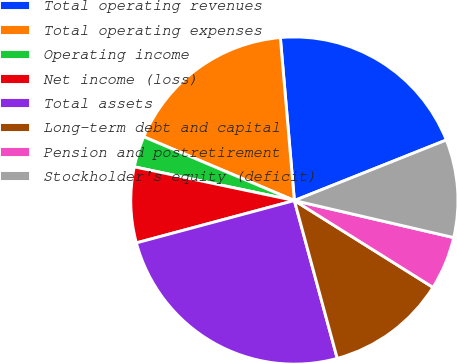Convert chart to OTSL. <chart><loc_0><loc_0><loc_500><loc_500><pie_chart><fcel>Total operating revenues<fcel>Total operating expenses<fcel>Operating income<fcel>Net income (loss)<fcel>Total assets<fcel>Long-term debt and capital<fcel>Pension and postretirement<fcel>Stockholder's equity (deficit)<nl><fcel>20.33%<fcel>17.26%<fcel>3.07%<fcel>7.47%<fcel>25.05%<fcel>11.87%<fcel>5.27%<fcel>9.67%<nl></chart> 